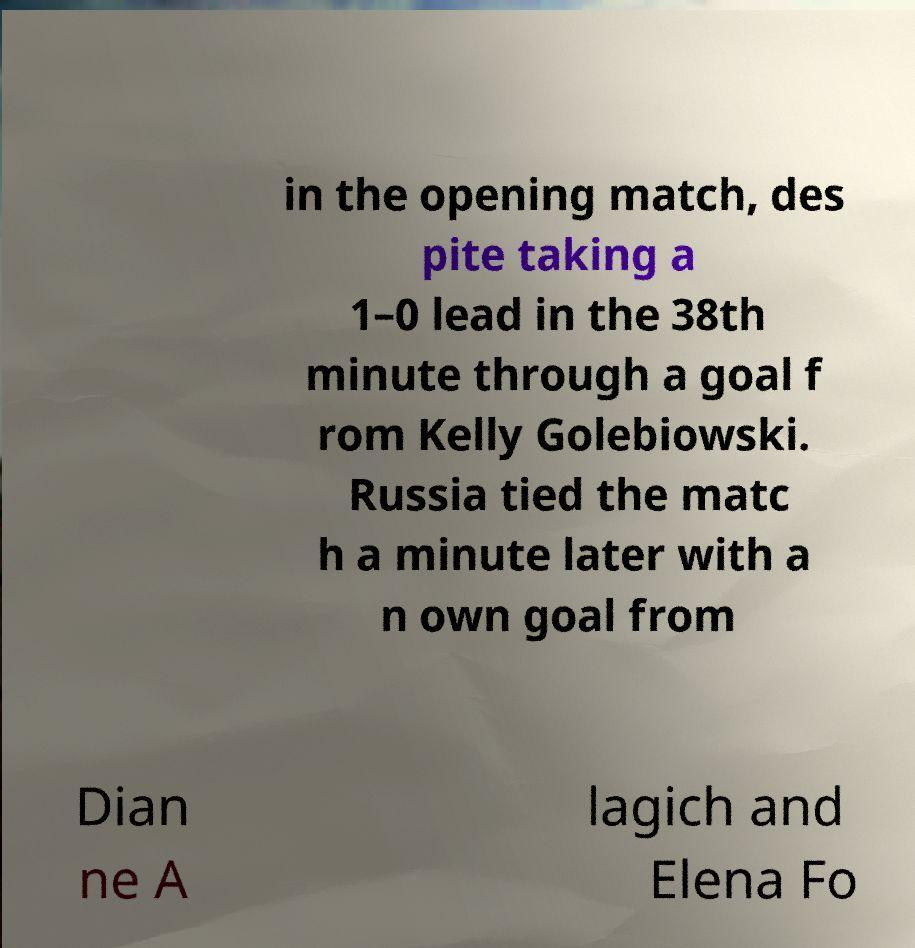Please read and relay the text visible in this image. What does it say? in the opening match, des pite taking a 1–0 lead in the 38th minute through a goal f rom Kelly Golebiowski. Russia tied the matc h a minute later with a n own goal from Dian ne A lagich and Elena Fo 